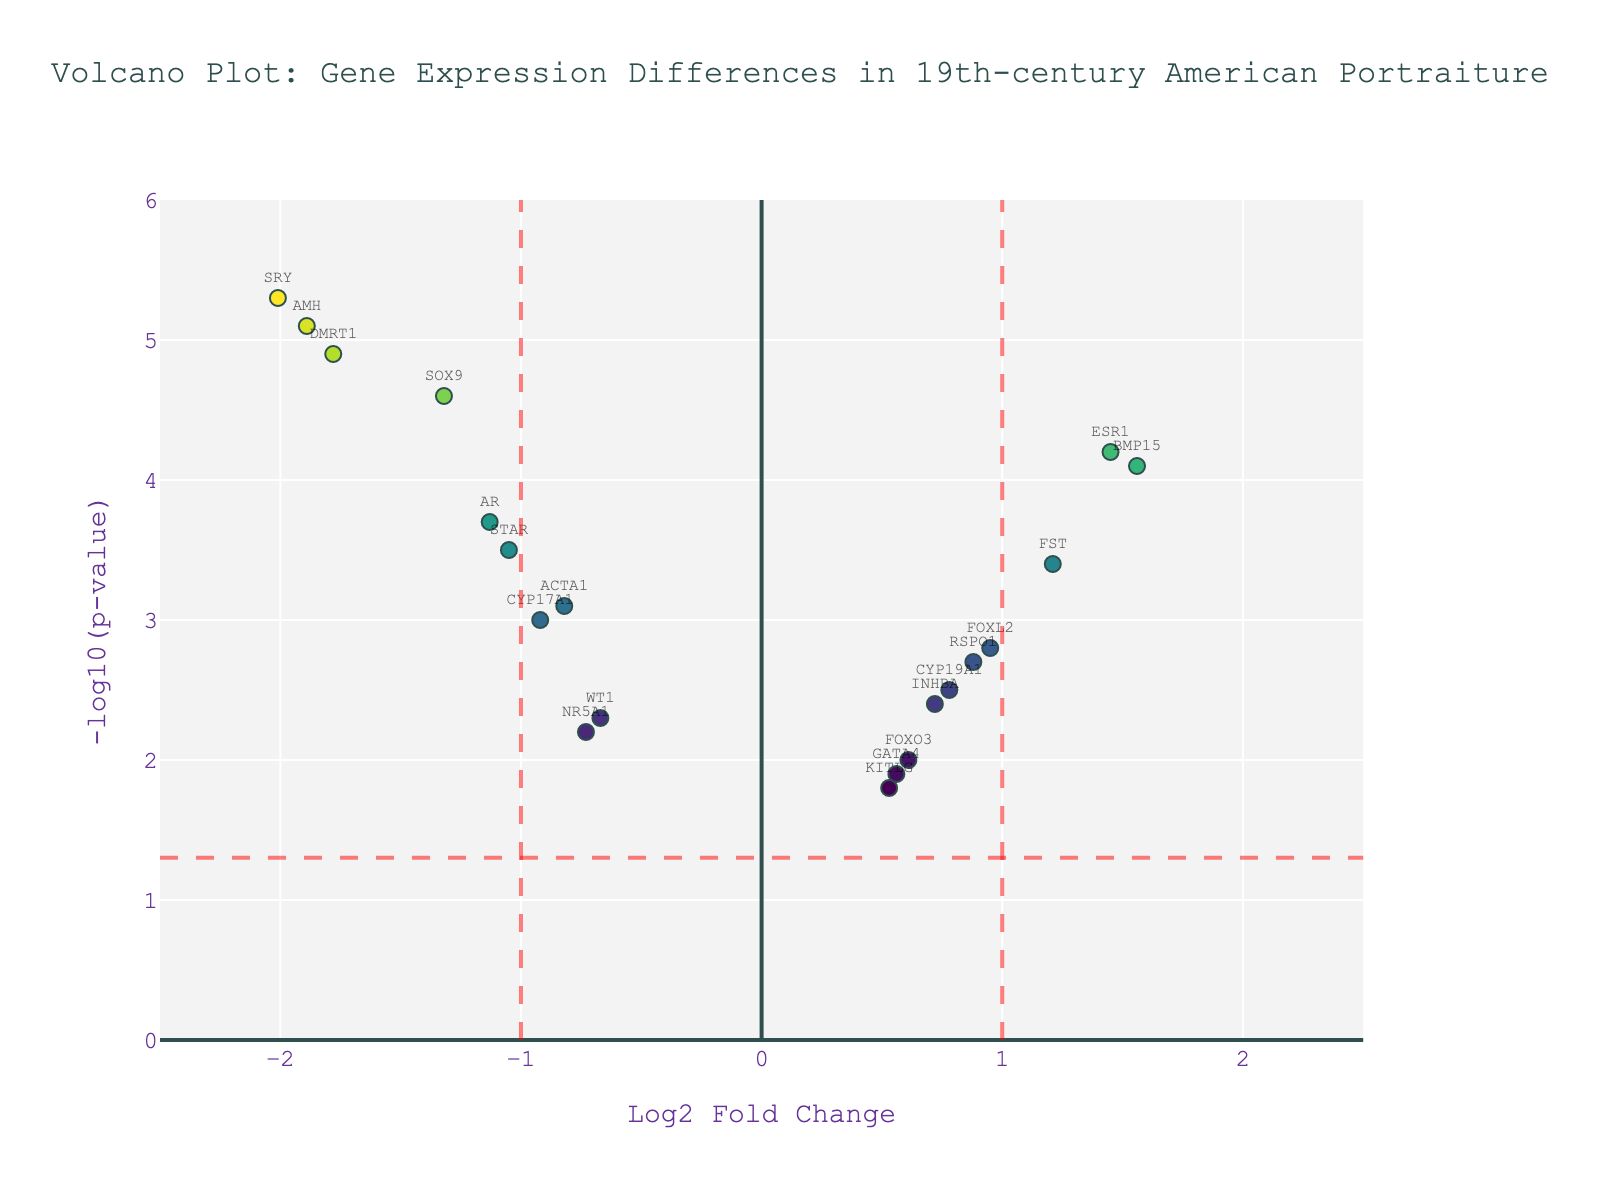What is the title of the plot? The title is written at the top of the plot. It reads, "Volcano Plot: Gene Expression Differences in 19th-century American Portraiture".
Answer: Volcano Plot: Gene Expression Differences in 19th-century American Portraiture How many gene points are displayed on the plot? By counting the number of markers on the plot, we find that there are 20 gene points.
Answer: 20 Which gene has the highest -log10(p-value)? By looking at the plot, the gene with the highest -log10(p-value) is the one represented with the highest y-axis value, which is SRY.
Answer: SRY Which gene has the lowest log2 fold change? The gene with the lowest log2 fold change is represented with the most negative x-axis value, which is SRY.
Answer: SRY What are the threshold values for log2 fold change and -log10(p-value)? The threshold lines are shown as red dashed lines on the plot. The log2 fold change thresholds are at ±1, and the -log10(p-value) threshold is at 1.3 (-log10(0.05)).
Answer: ±1 and 1.3 Which genes are considered significantly different in expression between male and female subjects? Significant genes are those beyond the red dashed lines. On the positive side of log2 fold change, they are ESR1, BMP15, and FST, while on the negative side, they are SRY, AR, SOX9, DMRT1, AMH, and STAR.
Answer: ESR1, BMP15, FST, SRY, AR, SOX9, DMRT1, AMH, and STAR Which gene has a log2 fold change greater than 1 but a -log10(p-value) less than 3? By observing the plot, the gene BMP15 has a log2 fold change greater than 1 and a -log10(p-value) slightly above 4. Therefore, no gene meets the criteria of log2 fold change greater than 1 but -log10(p-value) less than 3.
Answer: None How many genes have a -log10(p-value) greater than 4? By counting the number of points above the y-axis value of 4, we find there are 6 genes: ESR1, BMP15, SRY, SOX9, DMRT1, and AMH.
Answer: 6 Which gene exhibits the most significant difference in expression between male and female subjects in terms of p-value? The gene with the highest y-axis value (-log10(p-value)) shows the most significant difference. This gene is SRY.
Answer: SRY 